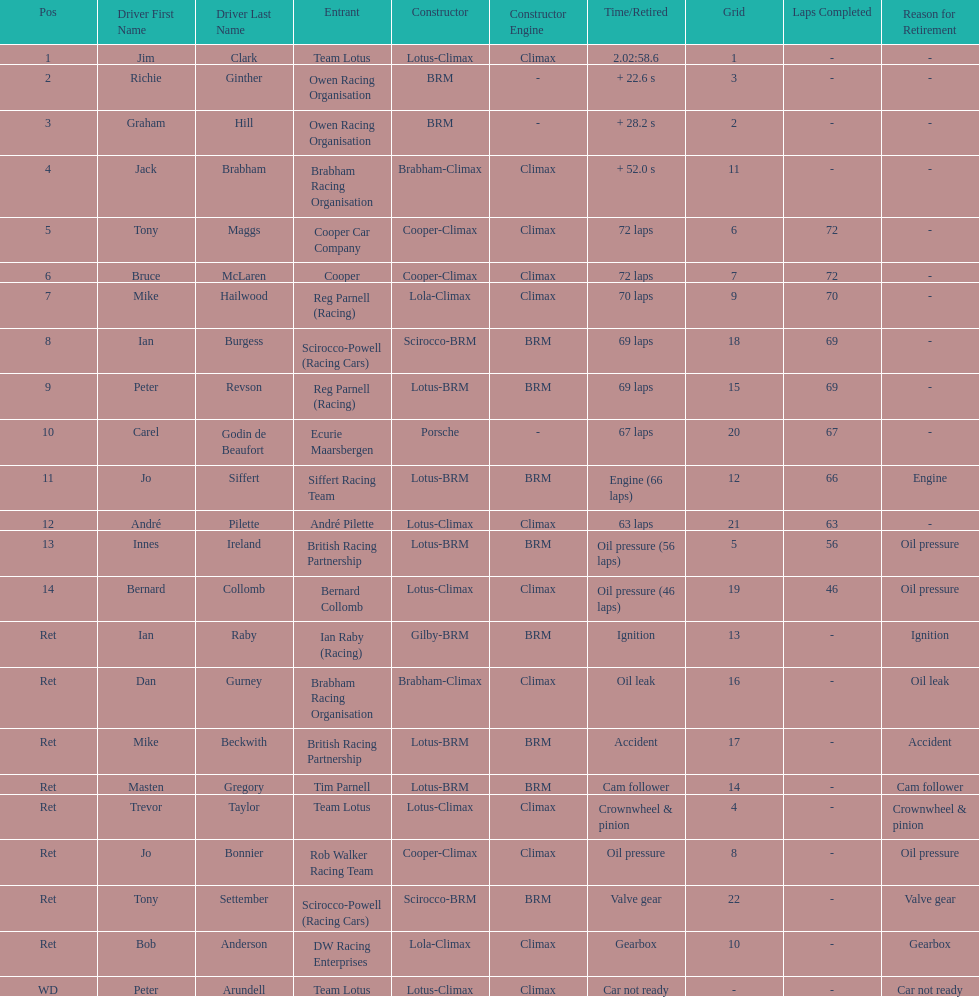Who came in first? Jim Clark. 